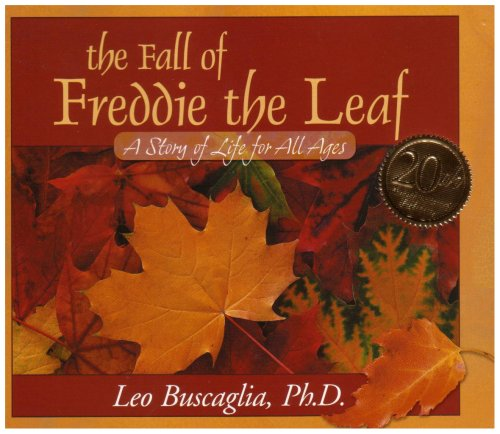What is the title of this book? The title of the book is 'The Fall of Freddie the Leaf: A Story of Life for All Ages.' It sheds light on life's cycles through a beautifully illustrated metaphor of a leaf named Freddie. 